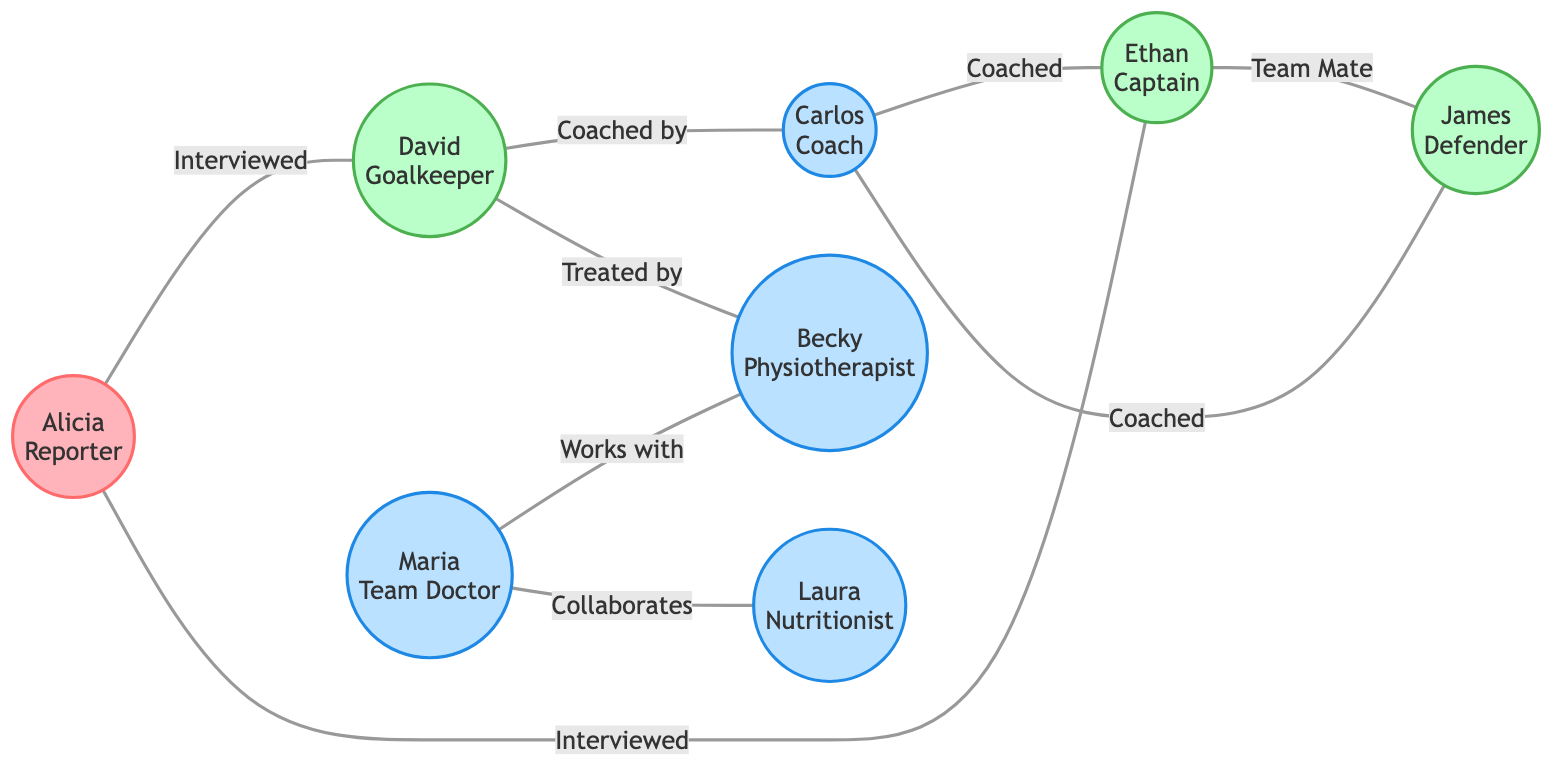What is the total number of nodes in this graph? The graph contains nodes representing individuals, which are Alicia, David, Maria, Carlos, Ethan, Becky, James, and Laura. Counting these gives a total of 8 nodes.
Answer: 8 What relationship does David have with Carlos? In the diagram, there is an edge that states David is 'Coached by' Carlos, indicating a direction of mentorship or training.
Answer: Coached by Who is the captain of the team? The node labeled Ethan corresponds to the role of Captain, which is explicitly stated in the diagram.
Answer: Ethan Which staff member collaborates with the Nutritionist? The relationship in the graph shows that Maria works with Becky and collaborates with Laura; thus, the Nutritionist (Laura) collaborates with Maria.
Answer: Maria How many players are there in the diagram? The graph lists players as David (Goalkeeper), Ethan (Captain), James (Defender), totaling to 3 players.
Answer: 3 What is the relationship between Ethan and James? According to the diagram, Ethan and James share the relationship of being 'Team Mate', indicating they are teammates on the soccer team.
Answer: Team Mate Which member of the team is treated by Becky? The diagram indicates that David is 'Treated by' Becky, showing a professional interaction concerning health or fitness.
Answer: David How many edges are connected to Carlos? Analyzing the graphic, Carlos is connected to 3 edges: he 'Coaches' Ethan, 'Coaches' James, and 'Coached by' David, giving a total of 3 edges.
Answer: 3 Who interviewed Alicia? The interactions in the diagram showcase Alicia interviewing David and Ethan, making them the individuals who conducted interviews with her.
Answer: David, Ethan 